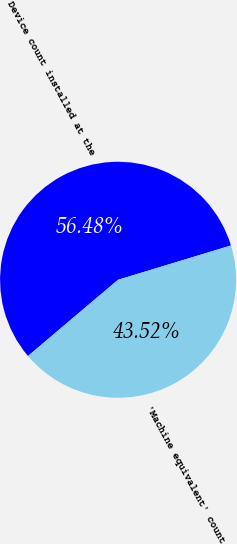<chart> <loc_0><loc_0><loc_500><loc_500><pie_chart><fcel>Device count installed at the<fcel>'Machine equivalent' count<nl><fcel>56.48%<fcel>43.52%<nl></chart> 